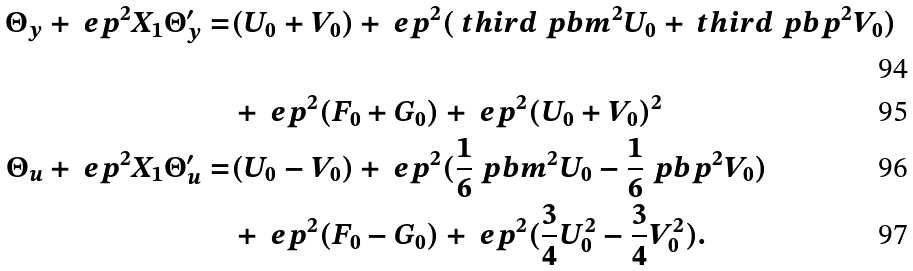Convert formula to latex. <formula><loc_0><loc_0><loc_500><loc_500>\Theta _ { y } + \ e p ^ { 2 } X _ { 1 } \Theta _ { y } ^ { \prime } = & ( U _ { 0 } + V _ { 0 } ) + \ e p ^ { 2 } ( \ t h i r d \ p b m ^ { 2 } U _ { 0 } + \ t h i r d \ p b p ^ { 2 } V _ { 0 } ) \\ & + \ e p ^ { 2 } ( F _ { 0 } + G _ { 0 } ) + \ e p ^ { 2 } ( U _ { 0 } + V _ { 0 } ) ^ { 2 } \\ \Theta _ { u } + \ e p ^ { 2 } X _ { 1 } \Theta _ { u } ^ { \prime } = & ( U _ { 0 } - V _ { 0 } ) + \ e p ^ { 2 } ( \frac { 1 } { 6 } \ p b m ^ { 2 } U _ { 0 } - \frac { 1 } { 6 } \ p b p ^ { 2 } V _ { 0 } ) \\ & + \ e p ^ { 2 } ( F _ { 0 } - G _ { 0 } ) + \ e p ^ { 2 } ( \frac { 3 } { 4 } U _ { 0 } ^ { 2 } - \frac { 3 } { 4 } V _ { 0 } ^ { 2 } ) .</formula> 